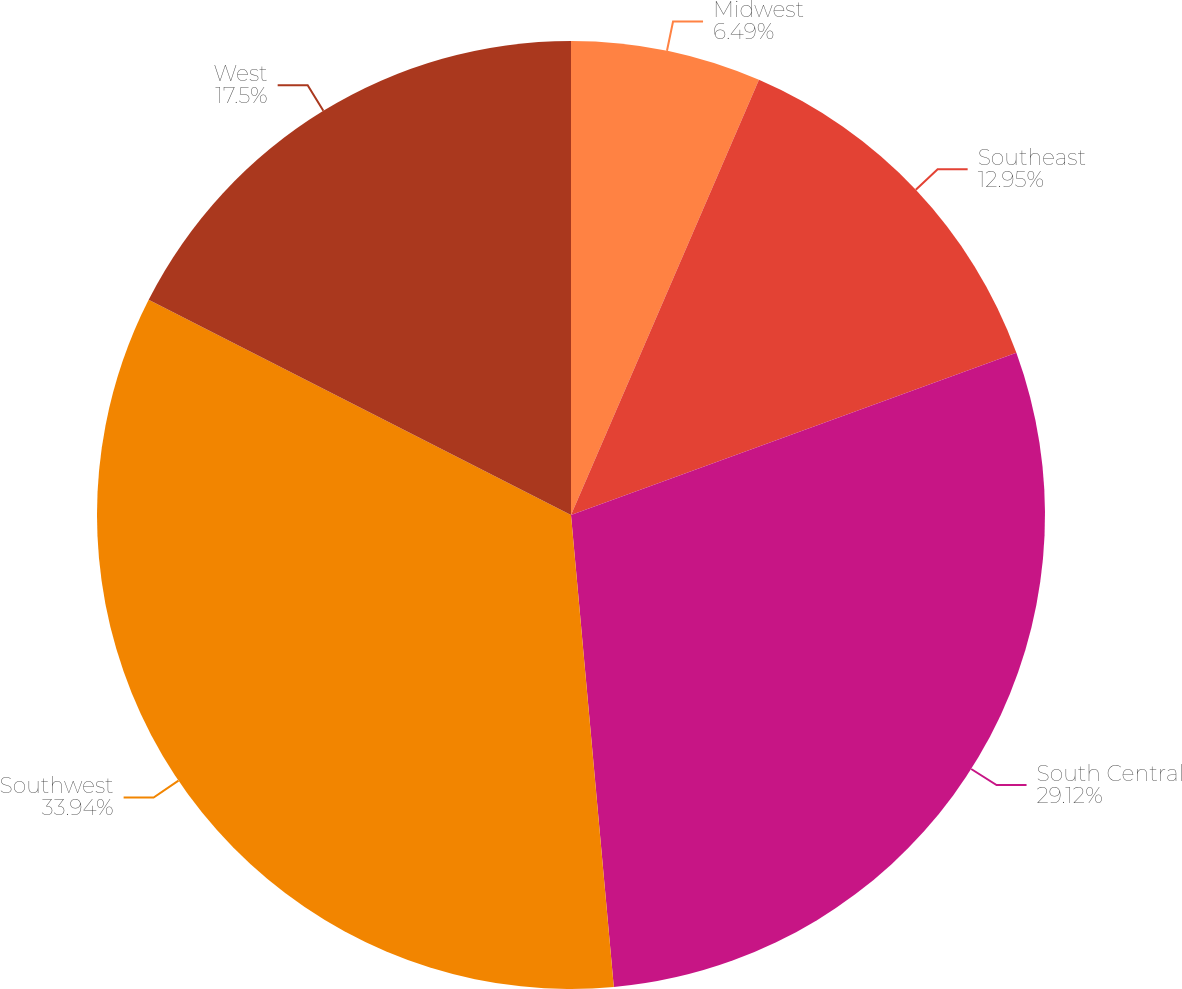Convert chart to OTSL. <chart><loc_0><loc_0><loc_500><loc_500><pie_chart><fcel>Midwest<fcel>Southeast<fcel>South Central<fcel>Southwest<fcel>West<nl><fcel>6.49%<fcel>12.95%<fcel>29.12%<fcel>33.94%<fcel>17.5%<nl></chart> 